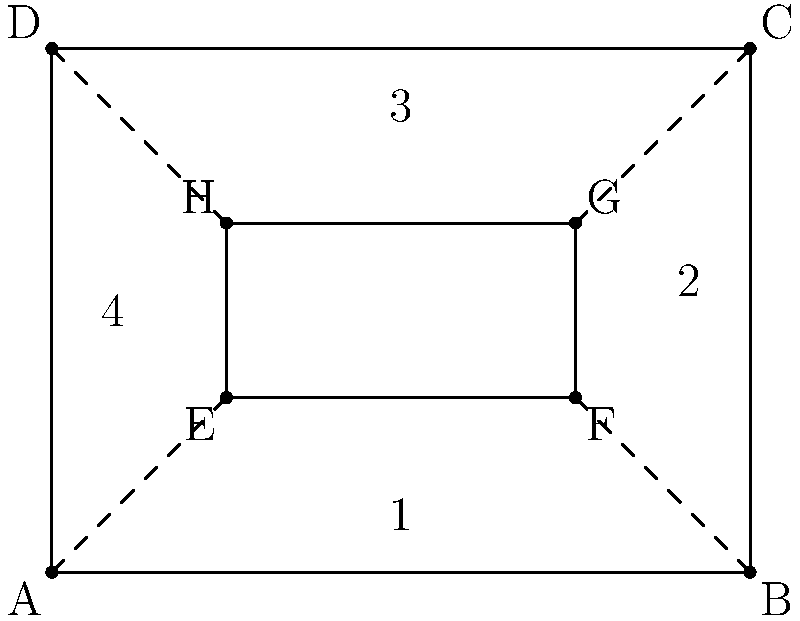In the diagram, ABCD represents a surgical incision, and EFGH represents the suture pattern. Which of the following statements about the congruence of the suture pattern is correct and essential for optimal wound closure? To determine the congruence of the suture pattern and its importance for optimal wound closure, we need to analyze the diagram step by step:

1. Observe that ABCD is a rectangle representing the surgical incision.
2. EFGH is also a rectangle, representing the suture pattern inside ABCD.
3. The dashed lines connect the corners of EFGH to the corners of ABCD, dividing the space between them into four regions (labeled 1, 2, 3, and 4).

Now, let's examine the congruence properties:

4. Opposite sides of rectangle EFGH are parallel and equal in length.
5. The dashed lines from each corner of EFGH to the corresponding corner of ABCD appear to be equal in length.
6. This creates four congruent trapezoids (regions 1, 2, 3, and 4).

For optimal wound closure:

7. Congruent trapezoids ensure equal tension distribution along the wound edges.
8. Equal tension prevents puckering or excessive stress on any part of the incision.
9. Uniform suture spacing (represented by the congruent trapezoids) promotes even healing and minimizes scarring.

Therefore, the correct statement is that all four regions created by the suture pattern are congruent trapezoids, which is essential for optimal wound closure as it ensures uniform tension distribution and promotes even healing.
Answer: Congruent trapezoids ensure uniform tension distribution. 